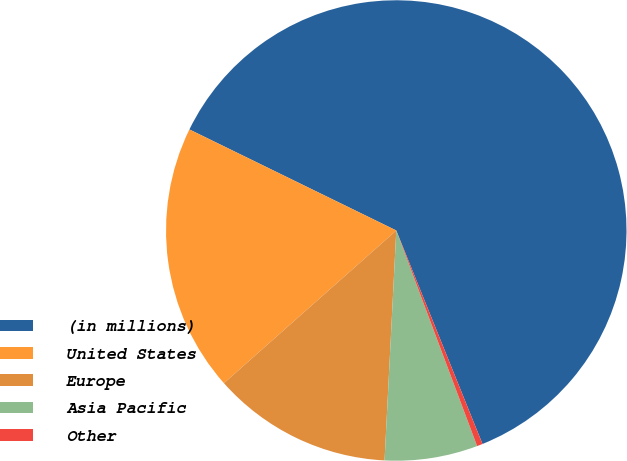<chart> <loc_0><loc_0><loc_500><loc_500><pie_chart><fcel>(in millions)<fcel>United States<fcel>Europe<fcel>Asia Pacific<fcel>Other<nl><fcel>61.66%<fcel>18.77%<fcel>12.65%<fcel>6.52%<fcel>0.4%<nl></chart> 